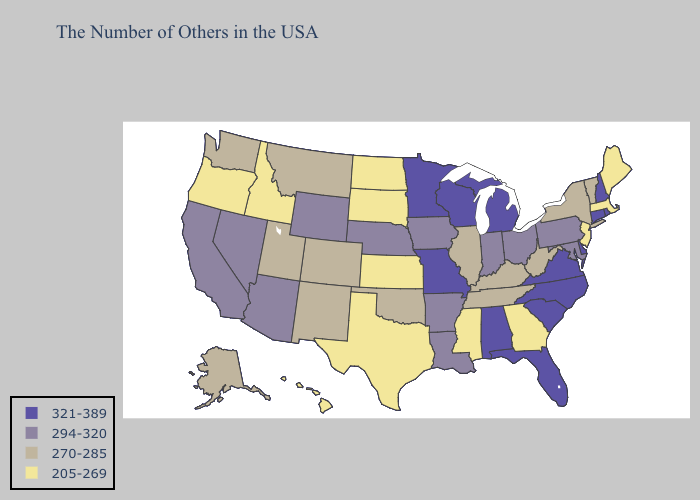Name the states that have a value in the range 321-389?
Concise answer only. Rhode Island, New Hampshire, Connecticut, Delaware, Virginia, North Carolina, South Carolina, Florida, Michigan, Alabama, Wisconsin, Missouri, Minnesota. Does Nevada have the highest value in the USA?
Keep it brief. No. Does the first symbol in the legend represent the smallest category?
Keep it brief. No. Among the states that border Idaho , does Montana have the lowest value?
Give a very brief answer. No. What is the value of Hawaii?
Give a very brief answer. 205-269. What is the value of Arizona?
Answer briefly. 294-320. What is the value of Arkansas?
Be succinct. 294-320. Does Oklahoma have the highest value in the USA?
Give a very brief answer. No. Does the map have missing data?
Concise answer only. No. Name the states that have a value in the range 321-389?
Give a very brief answer. Rhode Island, New Hampshire, Connecticut, Delaware, Virginia, North Carolina, South Carolina, Florida, Michigan, Alabama, Wisconsin, Missouri, Minnesota. Which states have the highest value in the USA?
Quick response, please. Rhode Island, New Hampshire, Connecticut, Delaware, Virginia, North Carolina, South Carolina, Florida, Michigan, Alabama, Wisconsin, Missouri, Minnesota. Name the states that have a value in the range 205-269?
Quick response, please. Maine, Massachusetts, New Jersey, Georgia, Mississippi, Kansas, Texas, South Dakota, North Dakota, Idaho, Oregon, Hawaii. Which states have the lowest value in the USA?
Short answer required. Maine, Massachusetts, New Jersey, Georgia, Mississippi, Kansas, Texas, South Dakota, North Dakota, Idaho, Oregon, Hawaii. What is the lowest value in the MidWest?
Give a very brief answer. 205-269. 